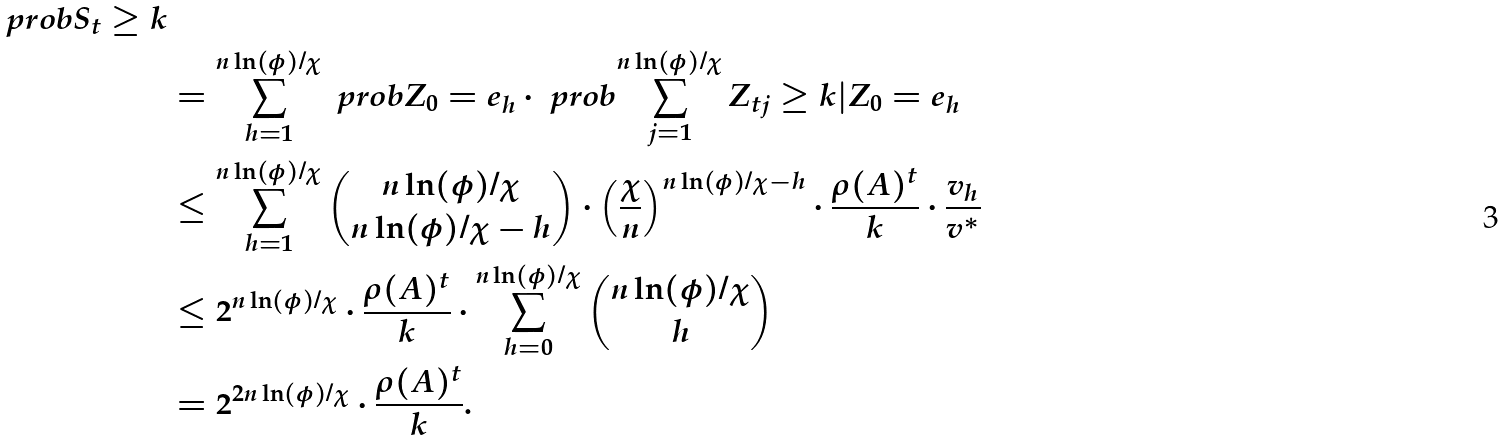<formula> <loc_0><loc_0><loc_500><loc_500>{ \ p r o b { S _ { t } \geq k } } \\ & = \sum _ { h = 1 } ^ { n \ln ( \phi ) / \chi } \ p r o b { Z _ { 0 } = e _ { h } } \cdot \ p r o b { \sum _ { j = 1 } ^ { n \ln ( \phi ) / \chi } Z _ { t j } \geq k | Z _ { 0 } = e _ { h } } \\ & \leq \sum _ { h = 1 } ^ { n \ln ( \phi ) / \chi } { n \ln ( \phi ) / \chi \choose n \ln ( \phi ) / \chi - h } \cdot \left ( \frac { \chi } { n } \right ) ^ { n \ln ( \phi ) / \chi - h } \cdot \frac { \rho ( A ) ^ { t } } { k } \cdot \frac { v _ { h } } { v ^ { * } } \\ & \leq 2 ^ { n \ln ( \phi ) / \chi } \cdot \frac { \rho ( A ) ^ { t } } { k } \cdot \sum _ { h = 0 } ^ { n \ln ( \phi ) / \chi } { n \ln ( \phi ) / \chi \choose h } \\ & = 2 ^ { 2 n \ln ( \phi ) / \chi } \cdot \frac { \rho ( A ) ^ { t } } { k } .</formula> 